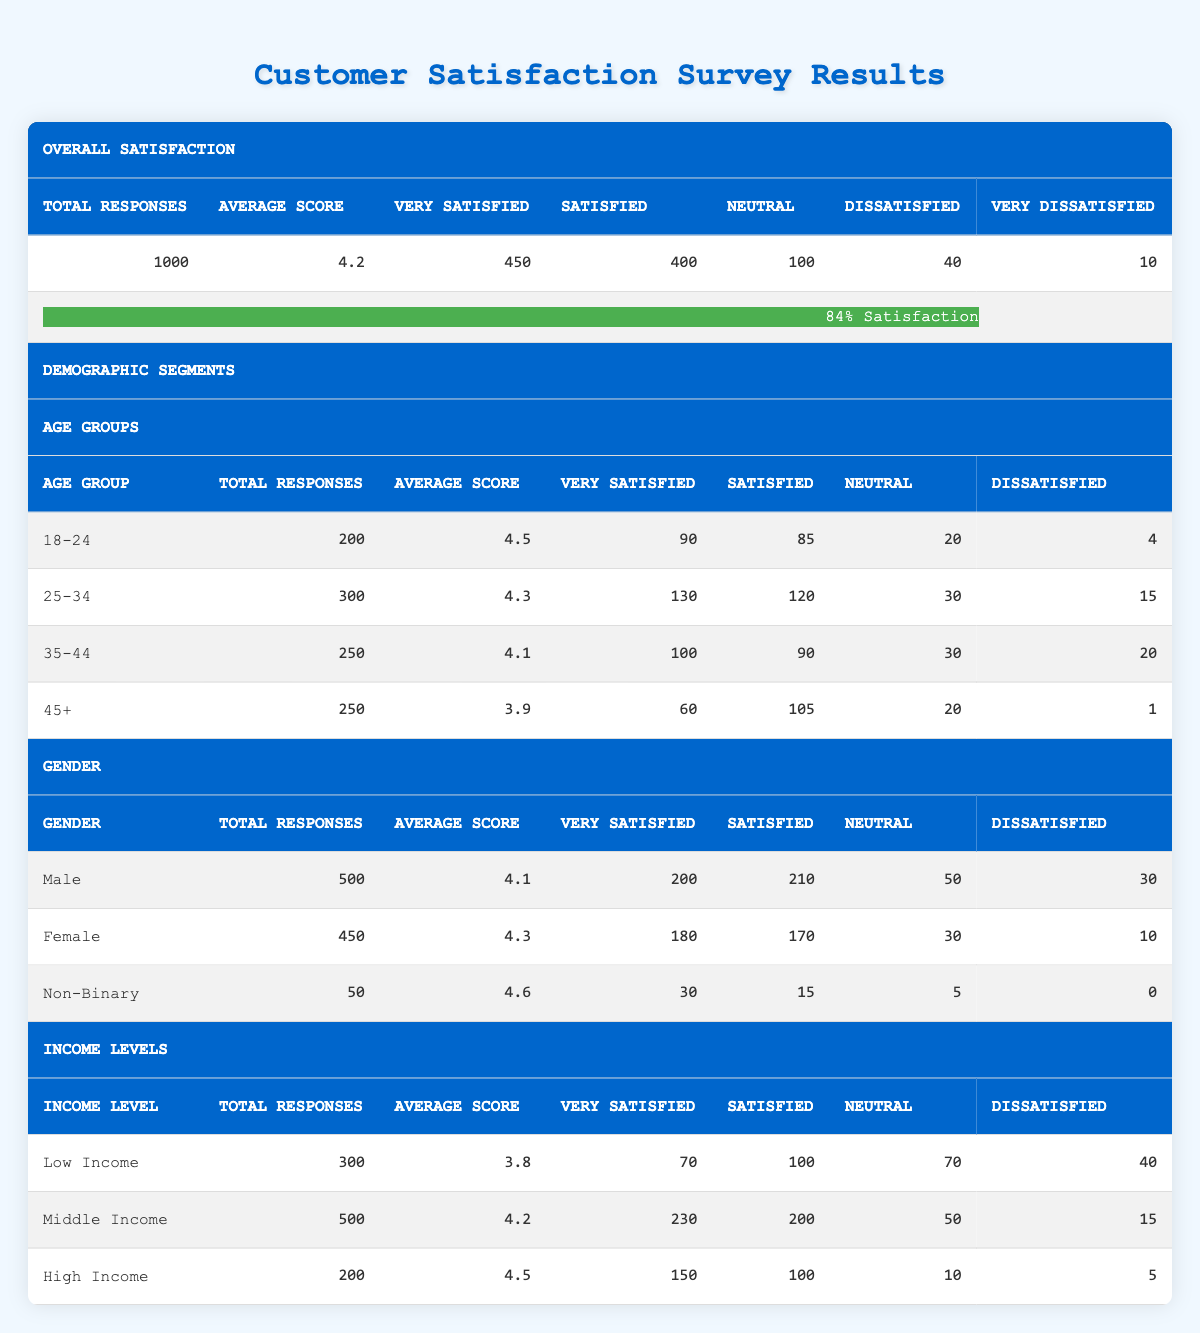What is the total number of respondents in the "25-34" age group? The table shows that for the "25-34" age group, the Total Responses column lists a figure of 300.
Answer: 300 What is the average score of respondents in the "Low Income" demographic? Looking at the Income Levels section, the table states that the Average Score for the "Low Income" group is 3.8.
Answer: 3.8 How many respondents indicated they were "Very Satisfied" in the "Male" category? The table reveals that 200 respondents in the "Male" category expressed they were "Very Satisfied."
Answer: 200 Is the average satisfaction score higher for "Non-Binary" respondents compared to "Female" respondents? The average score for "Non-Binary" is 4.6, while for "Female," it is 4.3. Since 4.6 is greater than 4.3, the average score is indeed higher for "Non-Binary" respondents.
Answer: Yes What is the total number of respondents who chose "Dissatisfied" across all demographic segments? To find this, we sum the "Dissatisfied" counts from each segment: 15 (25-34) + 20 (35-44) + 1 (45+) + 30 (Male) + 10 (Female) + 0 (Non-Binary) + 40 (Low Income) + 15 (Middle Income) + 5 (High Income) = 136.
Answer: 136 Which age group has the highest average satisfaction score? The average scores listed are 4.5 for "18-24," 4.3 for "25-34," 4.1 for "35-44," and 3.9 for "45+." The "18-24" age group has the highest score of 4.5.
Answer: 18-24 What is the difference in the number of "Very Satisfied" respondents between "High Income" and "Low Income"? For "High Income," the "Very Satisfied" count is 150 and for "Low Income," it is 70. So the difference is 150 - 70 = 80.
Answer: 80 How do the total responses of "Female" compare to "Male"? "Female" has 450 total responses, while "Male" has 500. Since 500 is greater than 450, "Male" has more responses.
Answer: Male has more responses In which demographic segment is the average score the lowest, and what is that score? Reviewing the averages, the lowest average score is from the "Low Income" segment, which is 3.8.
Answer: Low Income, 3.8 